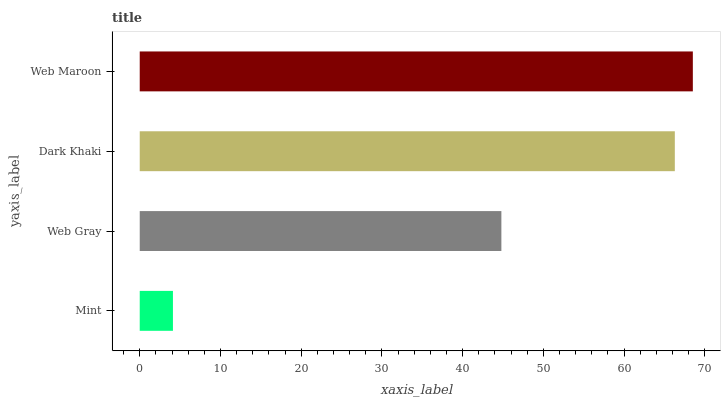Is Mint the minimum?
Answer yes or no. Yes. Is Web Maroon the maximum?
Answer yes or no. Yes. Is Web Gray the minimum?
Answer yes or no. No. Is Web Gray the maximum?
Answer yes or no. No. Is Web Gray greater than Mint?
Answer yes or no. Yes. Is Mint less than Web Gray?
Answer yes or no. Yes. Is Mint greater than Web Gray?
Answer yes or no. No. Is Web Gray less than Mint?
Answer yes or no. No. Is Dark Khaki the high median?
Answer yes or no. Yes. Is Web Gray the low median?
Answer yes or no. Yes. Is Web Maroon the high median?
Answer yes or no. No. Is Dark Khaki the low median?
Answer yes or no. No. 